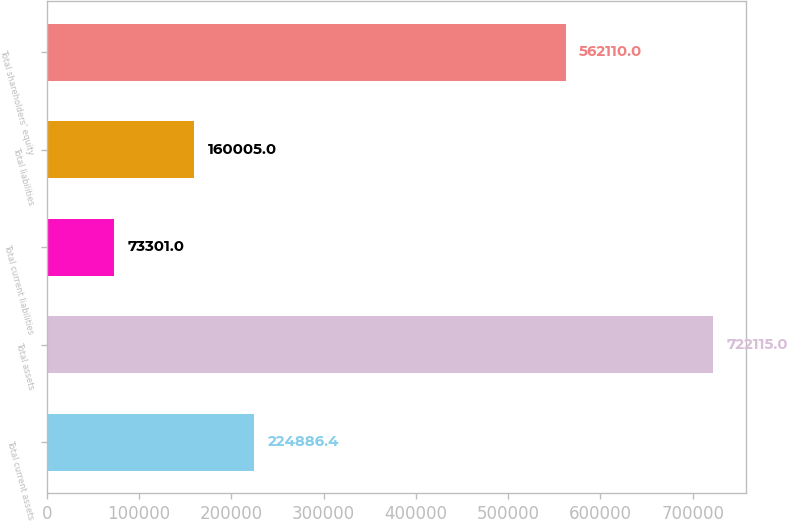<chart> <loc_0><loc_0><loc_500><loc_500><bar_chart><fcel>Total current assets<fcel>Total assets<fcel>Total current liabilities<fcel>Total liabilities<fcel>Total shareholders' equity<nl><fcel>224886<fcel>722115<fcel>73301<fcel>160005<fcel>562110<nl></chart> 